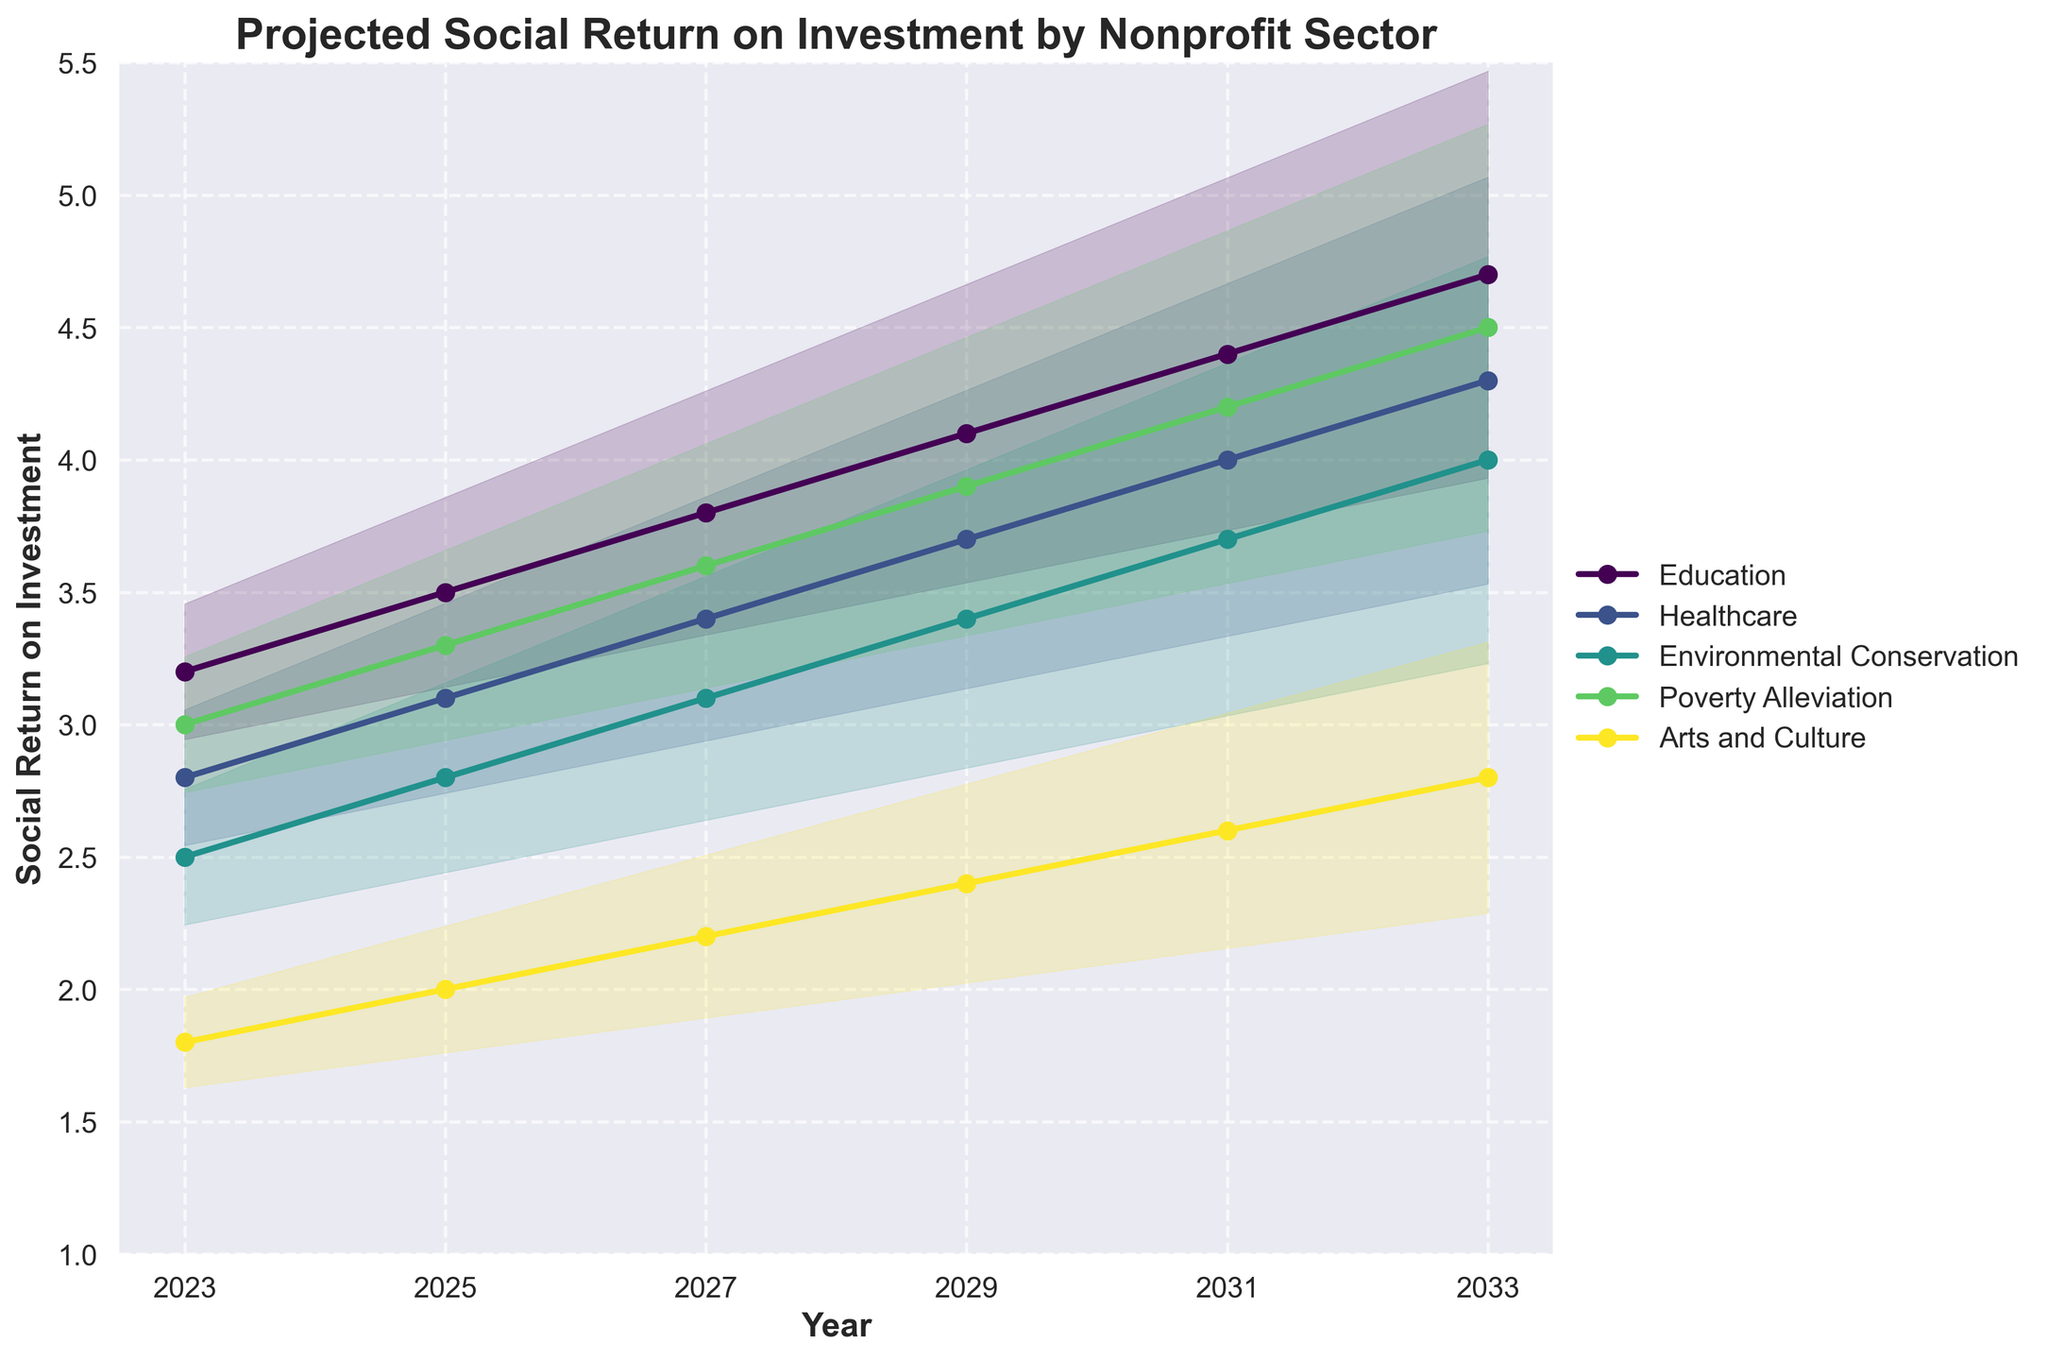What's the projected social return on investment for Education in 2029? The graph shows the value of Education in 2029 as one of the plot points. Trace the Education sector’s line to see where it reaches in 2029.
Answer: 4.1 What's the overall trend of social return on investment for the Healthcare sector from 2023 to 2033? Observe the direction of the Healthcare plot line from left (2023) to right (2033). It shows a rising trend from 2.8 in 2023 to 4.3 in 2033.
Answer: Increasing Which sector is projected to have the highest social return on investment in 2033? Look at the endpoints of the lines in 2033. The sector with the highest value at this point is the one with the highest projected return.
Answer: Education What is the difference in the social return on investment between Environmental Conservation and Arts & Culture in 2027? Identify both values at 2027 on their respective plot lines (3.1 for Environmental Conservation and 2.2 for Arts & Culture). Subtract the latter from the former: 3.1 - 2.2.
Answer: 0.9 How does the social return on investment for Poverty Alleviation compare to that for Healthcare in 2025? Follow the plot lines for Poverty Alleviation and Healthcare to see their corresponding values in 2025 (3.3 for Poverty Alleviation, 3.1 for Healthcare).
Answer: Poverty Alleviation is higher What is the range of uncertainty for the Arts & Culture sector in 2029? The fan chart shows a band of uncertainty around each line. For Arts & Culture in 2029, this band ranges from approximately 2.4 - 0.36 to 2.4 + 0.36.
Answer: 2.04 to 2.76 Which sector seems to show the most consistent growth in social return on investment over the years? Examine the smoothness and steadiness of each sector's plot line. The most linear and upward trend reveals the most consistent growth.
Answer: Education By how much does the projected social return on investment for the Environmental Conservation sector increase between 2023 and 2027? Identify Environmental Conservation values in 2023 and 2027 (2.5 and 3.1, respectively). Subtract the former from the latter: 3.1 - 2.5.
Answer: 0.6 If we visualize the predictions as a fan, which sector shows the widest uncertainty band in 2033? Assess the width of the shaded areas for each sector toward the right end of the graph. The sector with the broadest band of uncertainty in 2033 is the one with the widest fan.
Answer: Education 